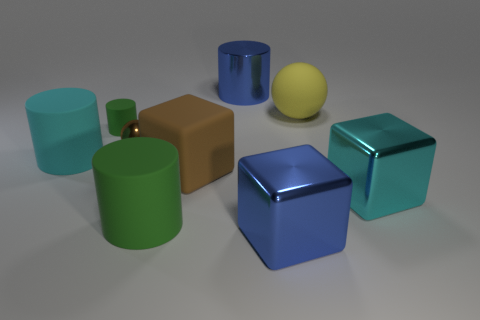Subtract 1 cylinders. How many cylinders are left? 3 Subtract all purple cylinders. Subtract all red balls. How many cylinders are left? 4 Add 1 blue metallic things. How many objects exist? 10 Subtract all balls. How many objects are left? 7 Add 4 brown cubes. How many brown cubes are left? 5 Add 8 brown shiny things. How many brown shiny things exist? 9 Subtract 0 purple cubes. How many objects are left? 9 Subtract all blue things. Subtract all small green things. How many objects are left? 6 